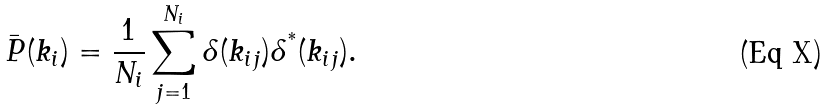Convert formula to latex. <formula><loc_0><loc_0><loc_500><loc_500>\bar { P } ( k _ { i } ) = \frac { 1 } { N _ { i } } \sum _ { j = 1 } ^ { N _ { i } } \delta ( { k } _ { i j } ) \delta ^ { ^ { * } } ( { k } _ { i j } ) .</formula> 